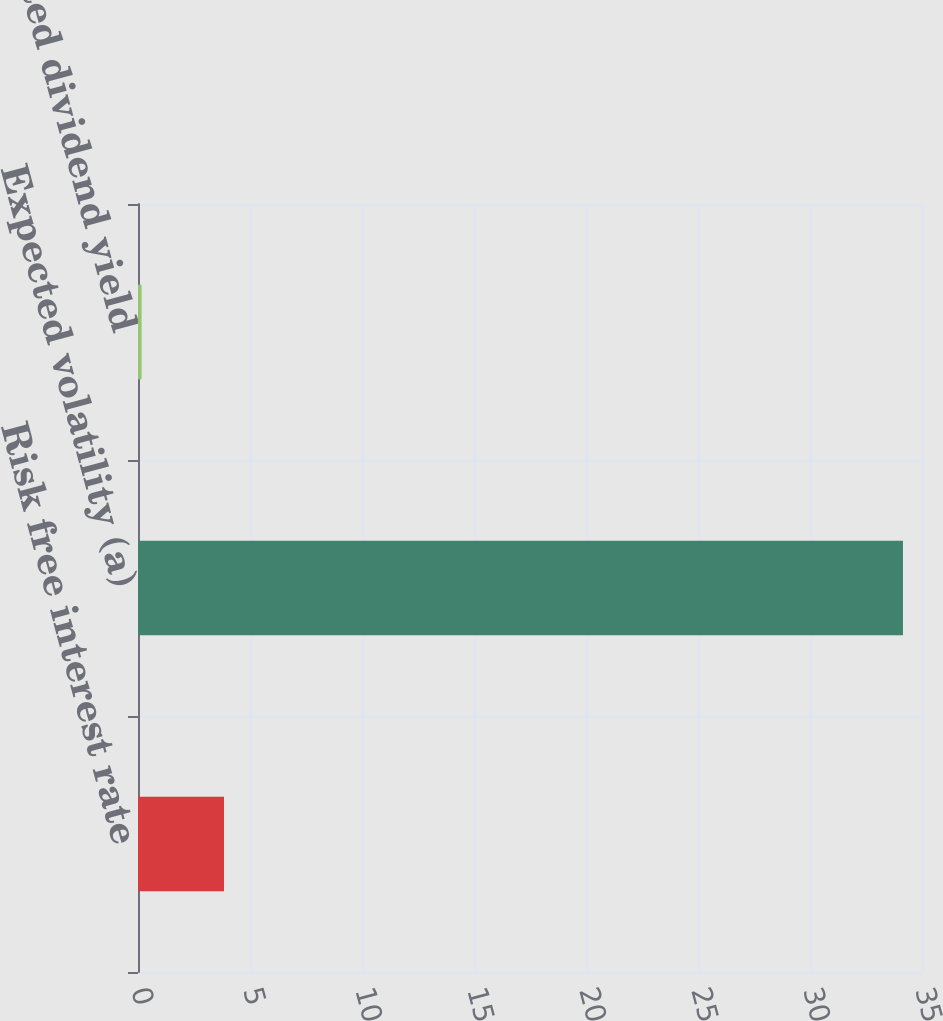<chart> <loc_0><loc_0><loc_500><loc_500><bar_chart><fcel>Risk free interest rate<fcel>Expected volatility (a)<fcel>Expected dividend yield<nl><fcel>3.84<fcel>34.15<fcel>0.16<nl></chart> 